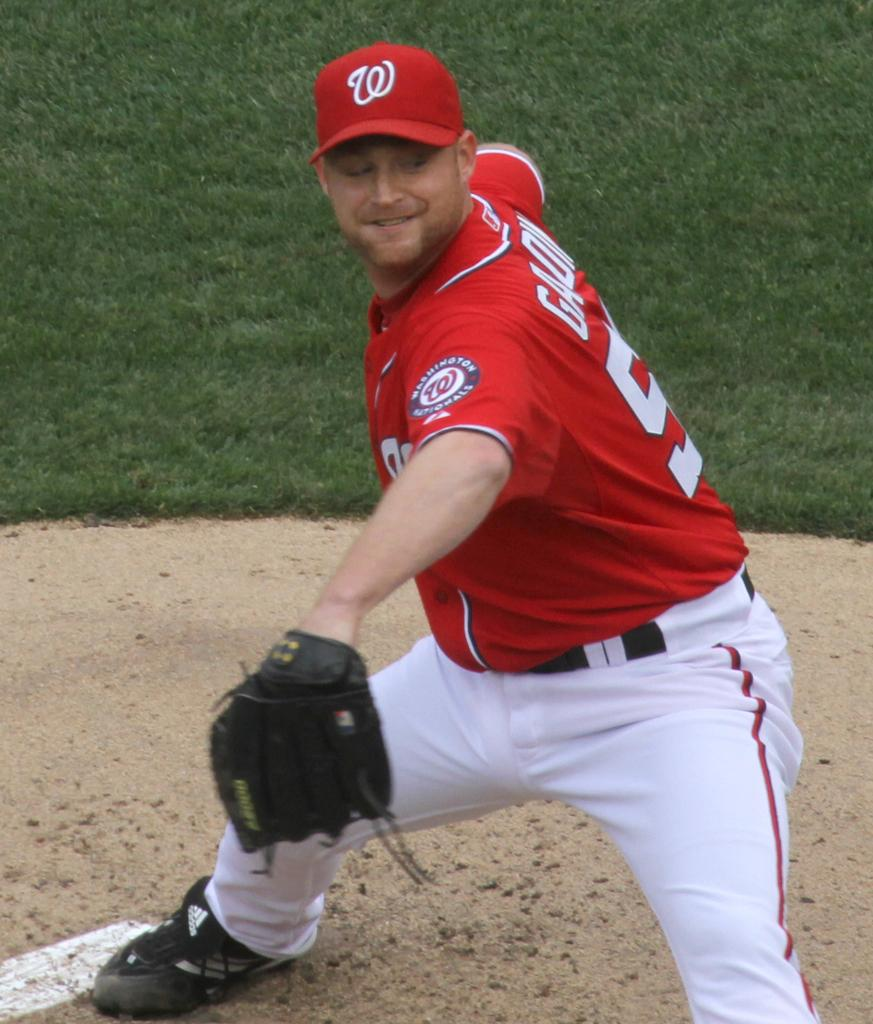<image>
Describe the image concisely. A player for the Washington Nationals is about to throw the ball. 